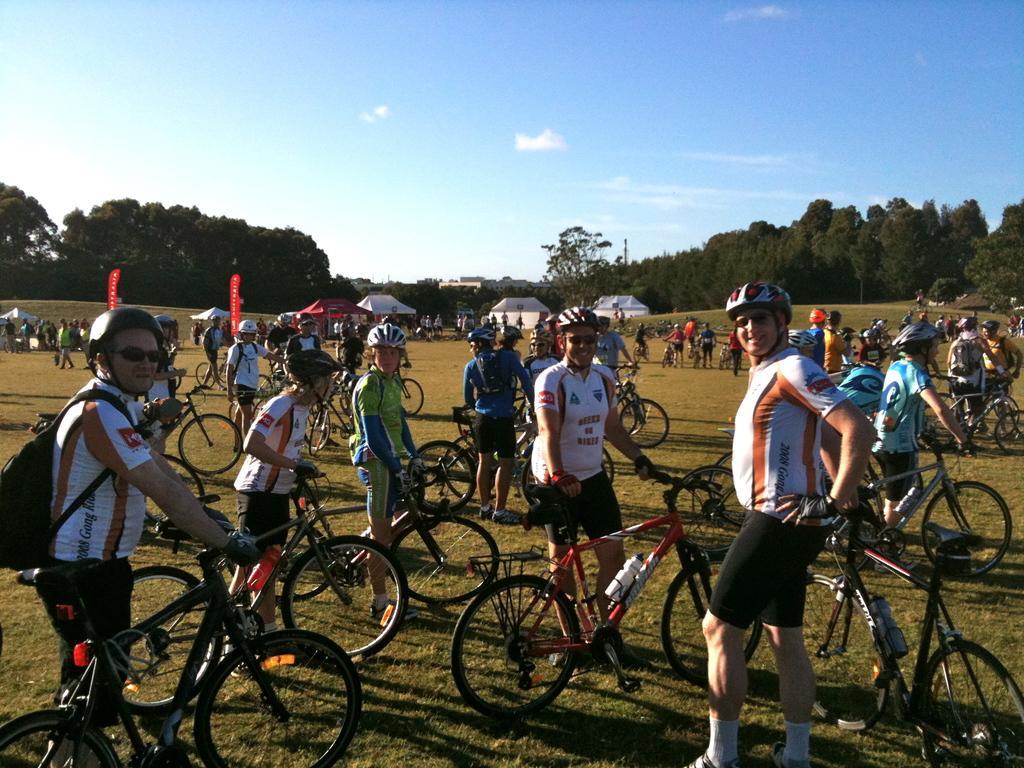Can you describe this image briefly? In this image I can see few person wearing white t shirt, helmets are standing and holding bicycles. In the background I can see few tents which are white in color, a tent which is red in color, few persons standing on the ground, few trees and the sky. 